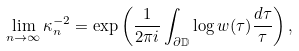<formula> <loc_0><loc_0><loc_500><loc_500>\lim _ { n \rightarrow \infty } \kappa _ { n } ^ { - 2 } = \exp \left ( \frac { 1 } { 2 \pi i } \int _ { \partial \mathbb { D } } \log w ( \tau ) \frac { d \tau } { \tau } \right ) ,</formula> 